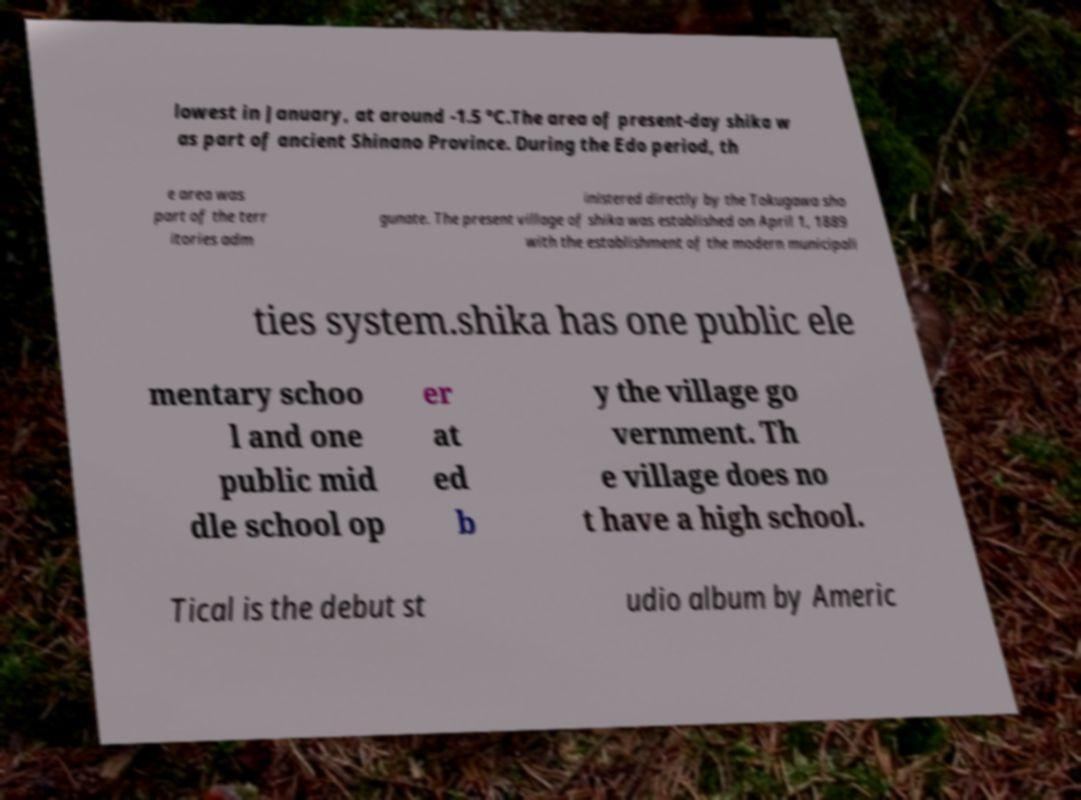Can you accurately transcribe the text from the provided image for me? lowest in January, at around -1.5 °C.The area of present-day shika w as part of ancient Shinano Province. During the Edo period, th e area was part of the terr itories adm inistered directly by the Tokugawa sho gunate. The present village of shika was established on April 1, 1889 with the establishment of the modern municipali ties system.shika has one public ele mentary schoo l and one public mid dle school op er at ed b y the village go vernment. Th e village does no t have a high school. Tical is the debut st udio album by Americ 